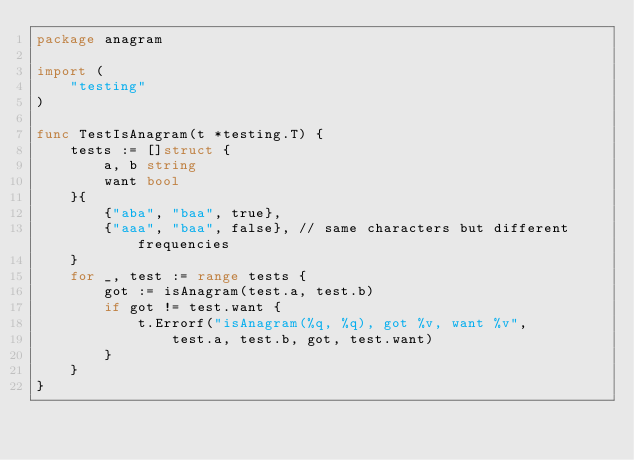Convert code to text. <code><loc_0><loc_0><loc_500><loc_500><_Go_>package anagram

import (
	"testing"
)

func TestIsAnagram(t *testing.T) {
	tests := []struct {
		a, b string
		want bool
	}{
		{"aba", "baa", true},
		{"aaa", "baa", false}, // same characters but different frequencies
	}
	for _, test := range tests {
		got := isAnagram(test.a, test.b)
		if got != test.want {
			t.Errorf("isAnagram(%q, %q), got %v, want %v",
				test.a, test.b, got, test.want)
		}
	}
}
</code> 